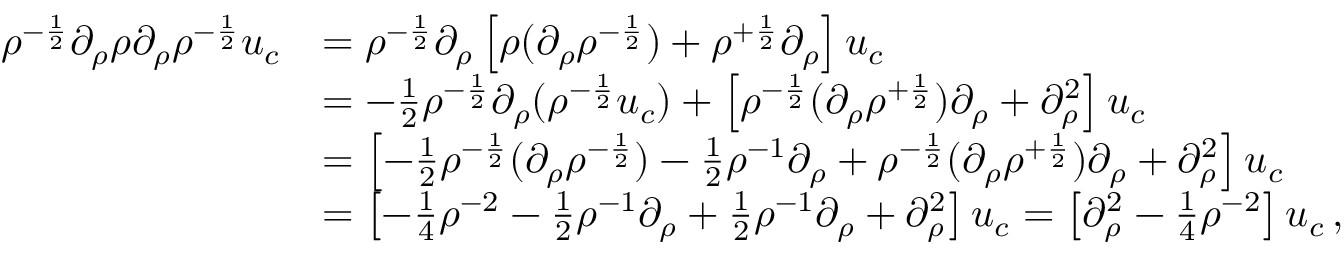Convert formula to latex. <formula><loc_0><loc_0><loc_500><loc_500>\begin{array} { r l } { \rho ^ { - \frac { 1 } { 2 } } \partial _ { \rho } \rho \partial _ { \rho } \rho ^ { - \frac { 1 } { 2 } } u _ { c } } & { = \rho ^ { - \frac { 1 } { 2 } } \partial _ { \rho } \left [ \rho ( \partial _ { \rho } \rho ^ { - \frac { 1 } { 2 } } ) + \rho ^ { + \frac { 1 } { 2 } } \partial _ { \rho } \right ] u _ { c } } \\ & { = - \frac { 1 } { 2 } \rho ^ { - \frac { 1 } { 2 } } \partial _ { \rho } ( \rho ^ { - \frac { 1 } { 2 } } u _ { c } ) + \left [ \rho ^ { - \frac { 1 } { 2 } } ( \partial _ { \rho } \rho ^ { + \frac { 1 } { 2 } } ) \partial _ { \rho } + \partial _ { \rho } ^ { 2 } \right ] u _ { c } } \\ & { = \left [ - \frac { 1 } { 2 } \rho ^ { - \frac { 1 } { 2 } } ( \partial _ { \rho } \rho ^ { - \frac { 1 } { 2 } } ) - \frac { 1 } { 2 } \rho ^ { - 1 } \partial _ { \rho } + \rho ^ { - \frac { 1 } { 2 } } ( \partial _ { \rho } \rho ^ { + \frac { 1 } { 2 } } ) \partial _ { \rho } + \partial _ { \rho } ^ { 2 } \right ] u _ { c } } \\ & { = \left [ - \frac { 1 } { 4 } \rho ^ { - 2 } - \frac { 1 } { 2 } \rho ^ { - 1 } \partial _ { \rho } + \frac { 1 } { 2 } \rho ^ { - 1 } \partial _ { \rho } + \partial _ { \rho } ^ { 2 } \right ] u _ { c } = \left [ \partial _ { \rho } ^ { 2 } - \frac { 1 } { 4 } \rho ^ { - 2 } \right ] u _ { c } \, , } \end{array}</formula> 